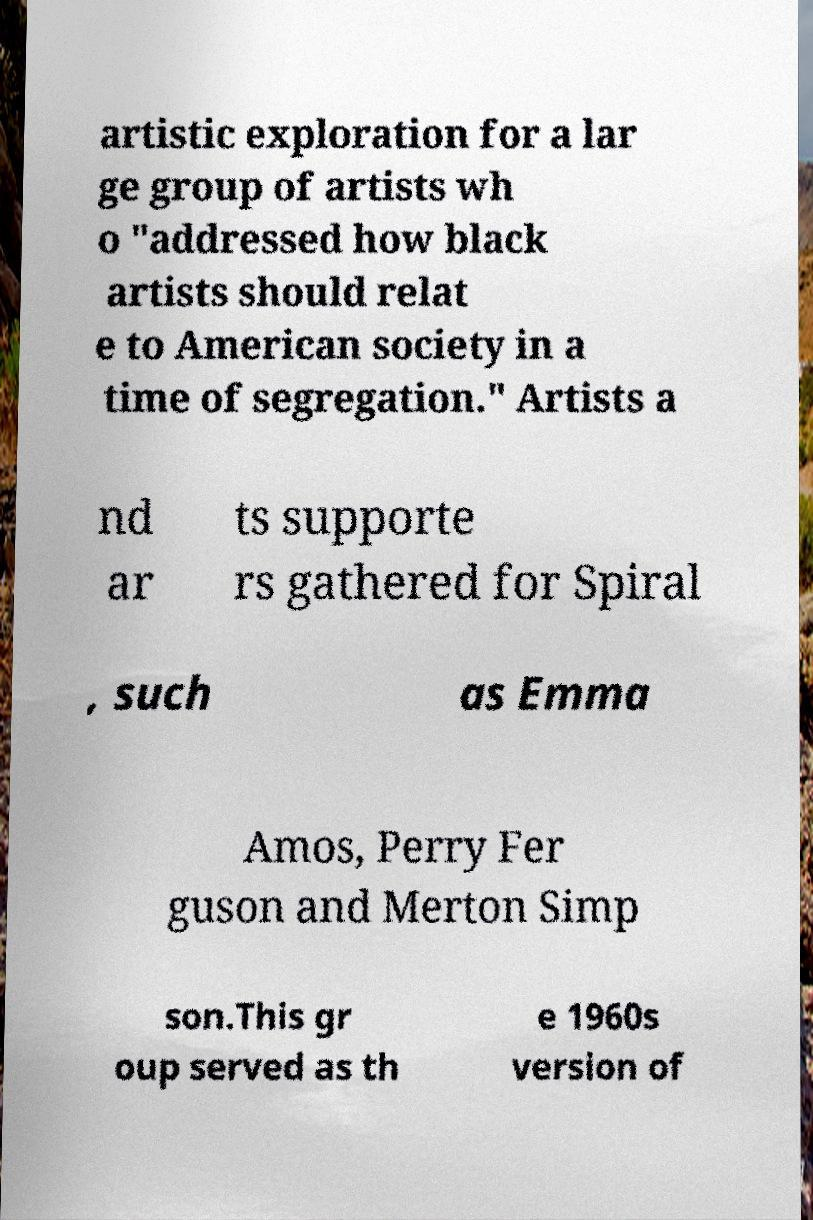Can you accurately transcribe the text from the provided image for me? artistic exploration for a lar ge group of artists wh o "addressed how black artists should relat e to American society in a time of segregation." Artists a nd ar ts supporte rs gathered for Spiral , such as Emma Amos, Perry Fer guson and Merton Simp son.This gr oup served as th e 1960s version of 